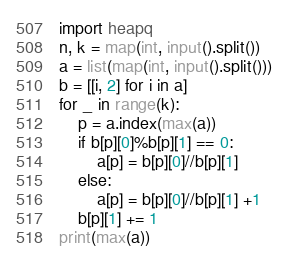Convert code to text. <code><loc_0><loc_0><loc_500><loc_500><_Python_>import heapq 
n, k = map(int, input().split())
a = list(map(int, input().split()))
b = [[i, 2] for i in a]
for _ in range(k):
    p = a.index(max(a))
    if b[p][0]%b[p][1] == 0:
        a[p] = b[p][0]//b[p][1]
    else:
        a[p] = b[p][0]//b[p][1] +1
    b[p][1] += 1
print(max(a))</code> 